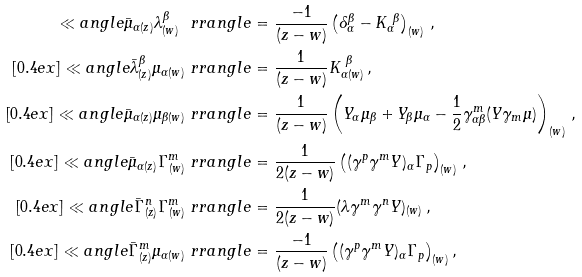Convert formula to latex. <formula><loc_0><loc_0><loc_500><loc_500>\ll a n g l e \bar { \mu } _ { \alpha ( z ) } \lambda ^ { \beta } _ { ( w ) } \ r r a n g l e & = \frac { - 1 } { ( z - w ) } \left ( \delta ^ { \beta } _ { \alpha } - K _ { \alpha } ^ { \ \beta } \right ) _ { ( w ) } \, , \\ [ 0 . 4 e x ] \ll a n g l e \bar { \lambda } ^ { \beta } _ { ( z ) } \mu _ { \alpha ( w ) } \ r r a n g l e & = \frac { 1 } { ( z - w ) } K _ { \alpha ( w ) } ^ { \ \beta } \, , \\ [ 0 . 4 e x ] \ll a n g l e \bar { \mu } _ { \alpha ( z ) } \mu _ { \beta ( w ) } \ r r a n g l e & = \frac { 1 } { ( z - w ) } \left ( Y _ { \alpha } \mu _ { \beta } + Y _ { \beta } \mu _ { \alpha } - \frac { 1 } { 2 } \gamma ^ { m } _ { \alpha \beta } ( Y \gamma _ { m } \mu ) \right ) _ { ( w ) } \, , \\ [ 0 . 4 e x ] \ll a n g l e \bar { \mu } _ { \alpha ( z ) } \Gamma ^ { m } _ { ( w ) } \ r r a n g l e & = \frac { 1 } { 2 ( z - w ) } \left ( ( \gamma ^ { p } \gamma ^ { m } Y ) _ { \alpha } \Gamma _ { p } \right ) _ { ( w ) } \, , \\ [ 0 . 4 e x ] \ll a n g l e \bar { \Gamma } ^ { n } _ { ( z ) } \Gamma ^ { m } _ { ( w ) } \ r r a n g l e & = \frac { 1 } { 2 ( z - w ) } ( \lambda \gamma ^ { m } \gamma ^ { n } Y ) _ { ( w ) } \, , \\ [ 0 . 4 e x ] \ll a n g l e \bar { \Gamma } ^ { m } _ { ( z ) } \mu _ { \alpha ( w ) } \ r r a n g l e & = \frac { - 1 } { ( z - w ) } \left ( ( \gamma ^ { p } \gamma ^ { m } Y ) _ { \alpha } \Gamma _ { p } \right ) _ { ( w ) } ,</formula> 